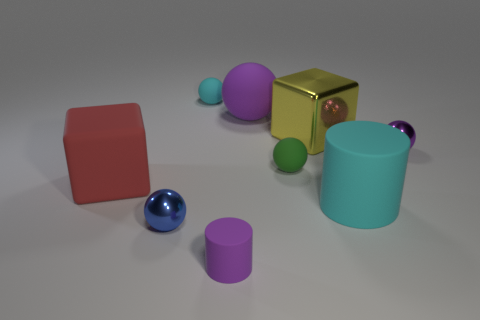How many big purple matte objects are behind the cylinder left of the cyan cylinder?
Provide a short and direct response. 1. Are there more red matte cubes behind the purple metal object than small spheres that are on the right side of the blue sphere?
Your response must be concise. No. What is the large purple thing made of?
Provide a short and direct response. Rubber. Are there any red things that have the same size as the green matte ball?
Your response must be concise. No. There is a cylinder that is the same size as the cyan rubber sphere; what is its material?
Your answer should be very brief. Rubber. How many small green metal balls are there?
Keep it short and to the point. 0. How big is the block left of the small blue metallic sphere?
Your response must be concise. Large. Are there the same number of cyan rubber balls to the right of the blue shiny ball and big purple rubber objects?
Provide a short and direct response. Yes. Are there any yellow things of the same shape as the large purple rubber object?
Your response must be concise. No. There is a rubber object that is behind the large red block and in front of the purple metallic ball; what is its shape?
Your response must be concise. Sphere. 